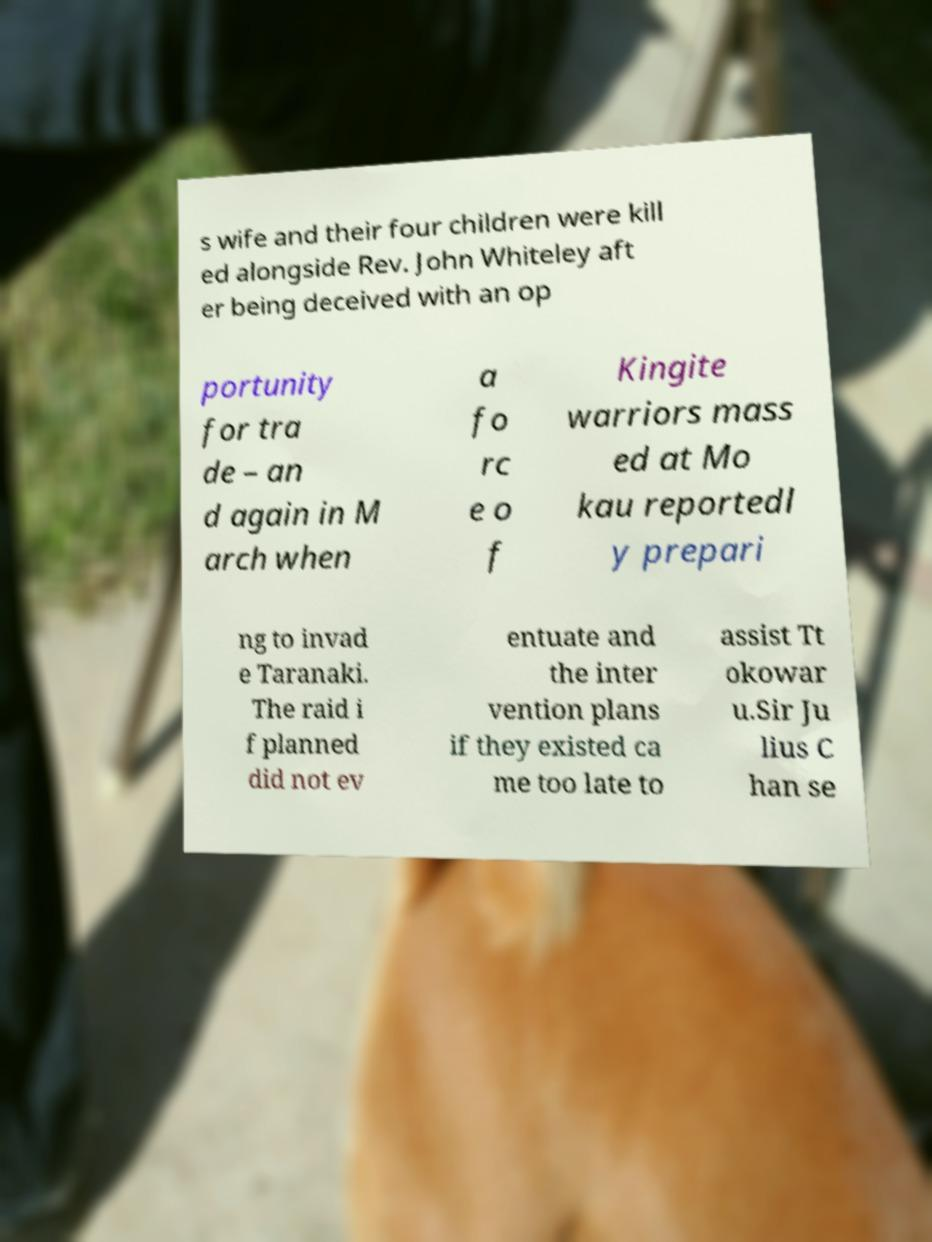Please identify and transcribe the text found in this image. s wife and their four children were kill ed alongside Rev. John Whiteley aft er being deceived with an op portunity for tra de – an d again in M arch when a fo rc e o f Kingite warriors mass ed at Mo kau reportedl y prepari ng to invad e Taranaki. The raid i f planned did not ev entuate and the inter vention plans if they existed ca me too late to assist Tt okowar u.Sir Ju lius C han se 